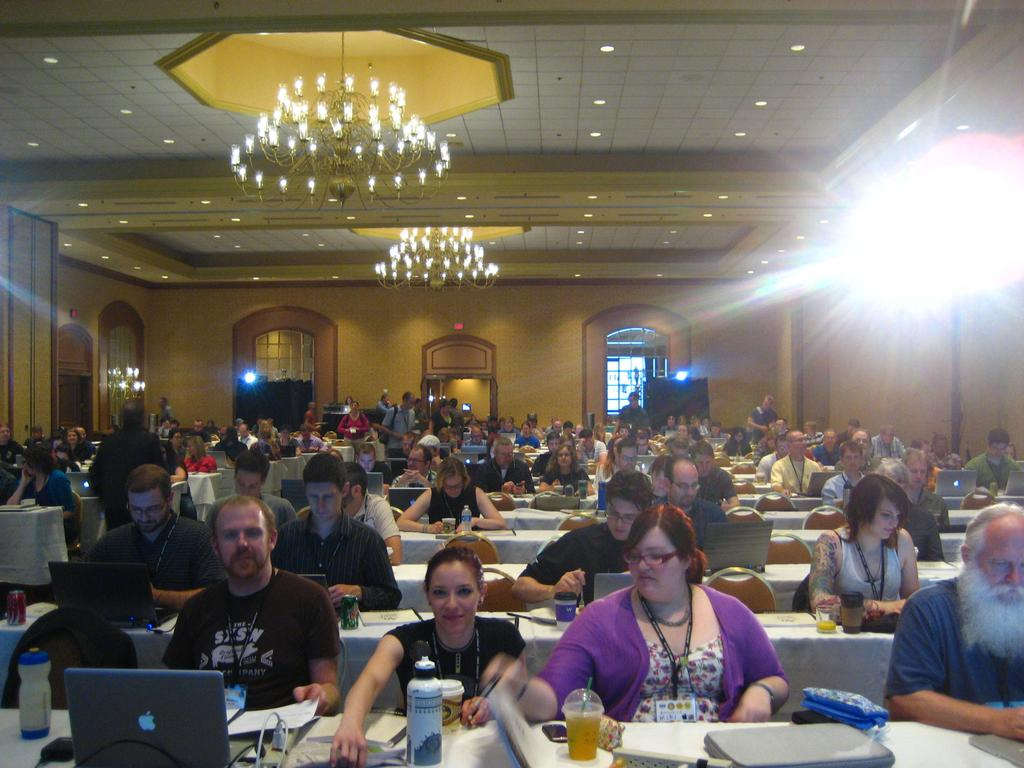What is the setting of the image? The setting of the image is a room. What are the people in the room doing? The people in the room are sitting on chairs. What is in front of the chairs? There is a table in front of the chairs. What objects are on the table? There are laptops on the table. What type of breakfast is being served on the table in the image? There is no breakfast present in the image; the table only has laptops on it. 